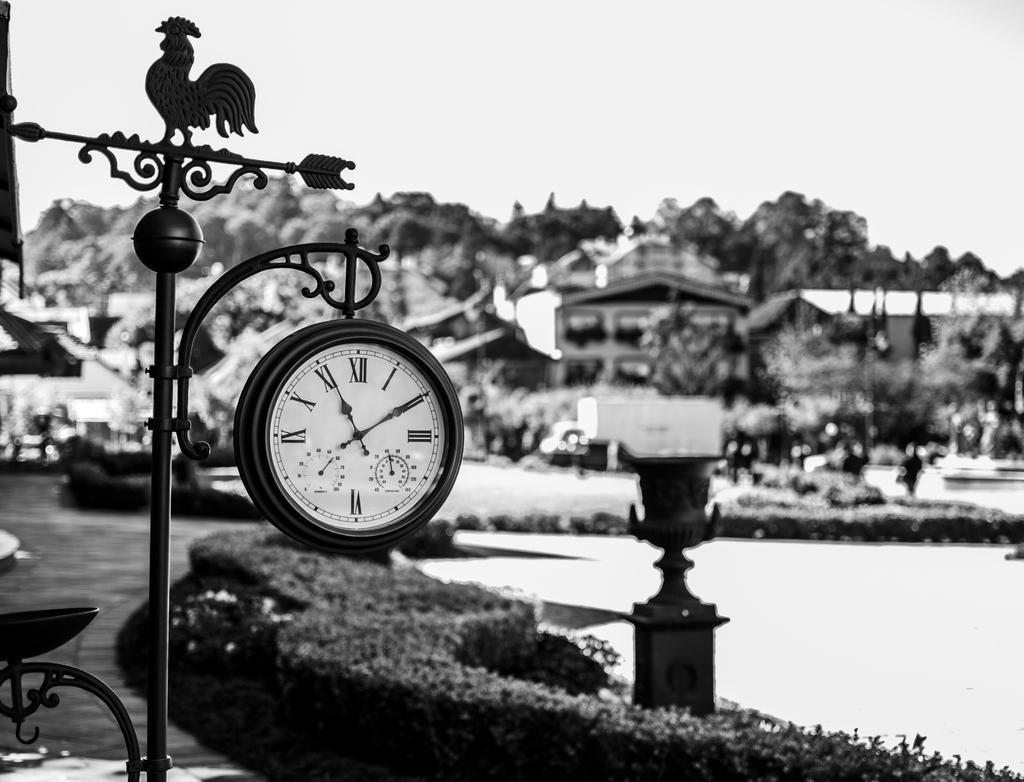Could you give a brief overview of what you see in this image? In this picture we can see a clock attached to a pole, here we can see plants and some objects on the ground and in the background we can see buildings, people, trees, sky and some objects. 